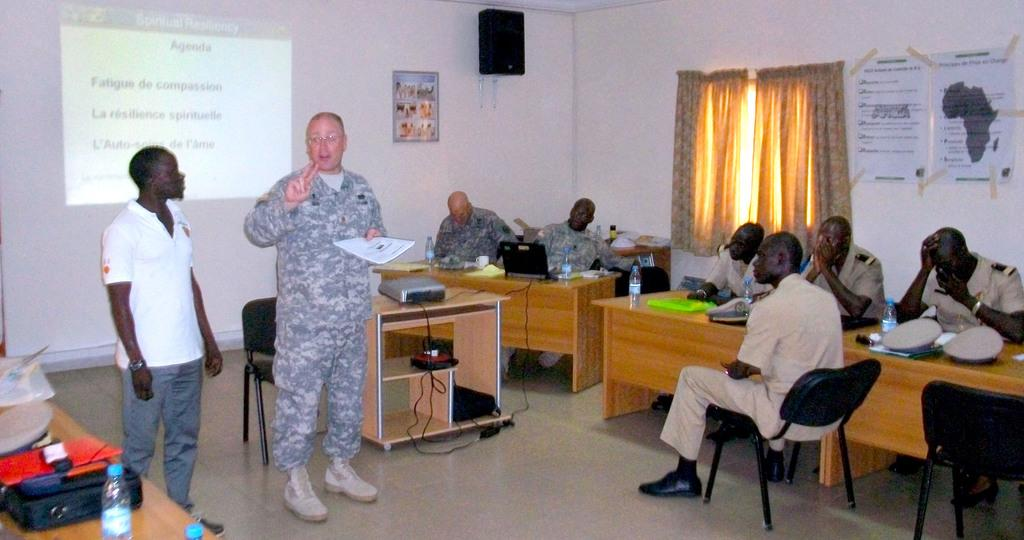<image>
Share a concise interpretation of the image provided. A power point presentation on a class room wall titled Spiritual Resiliency. 